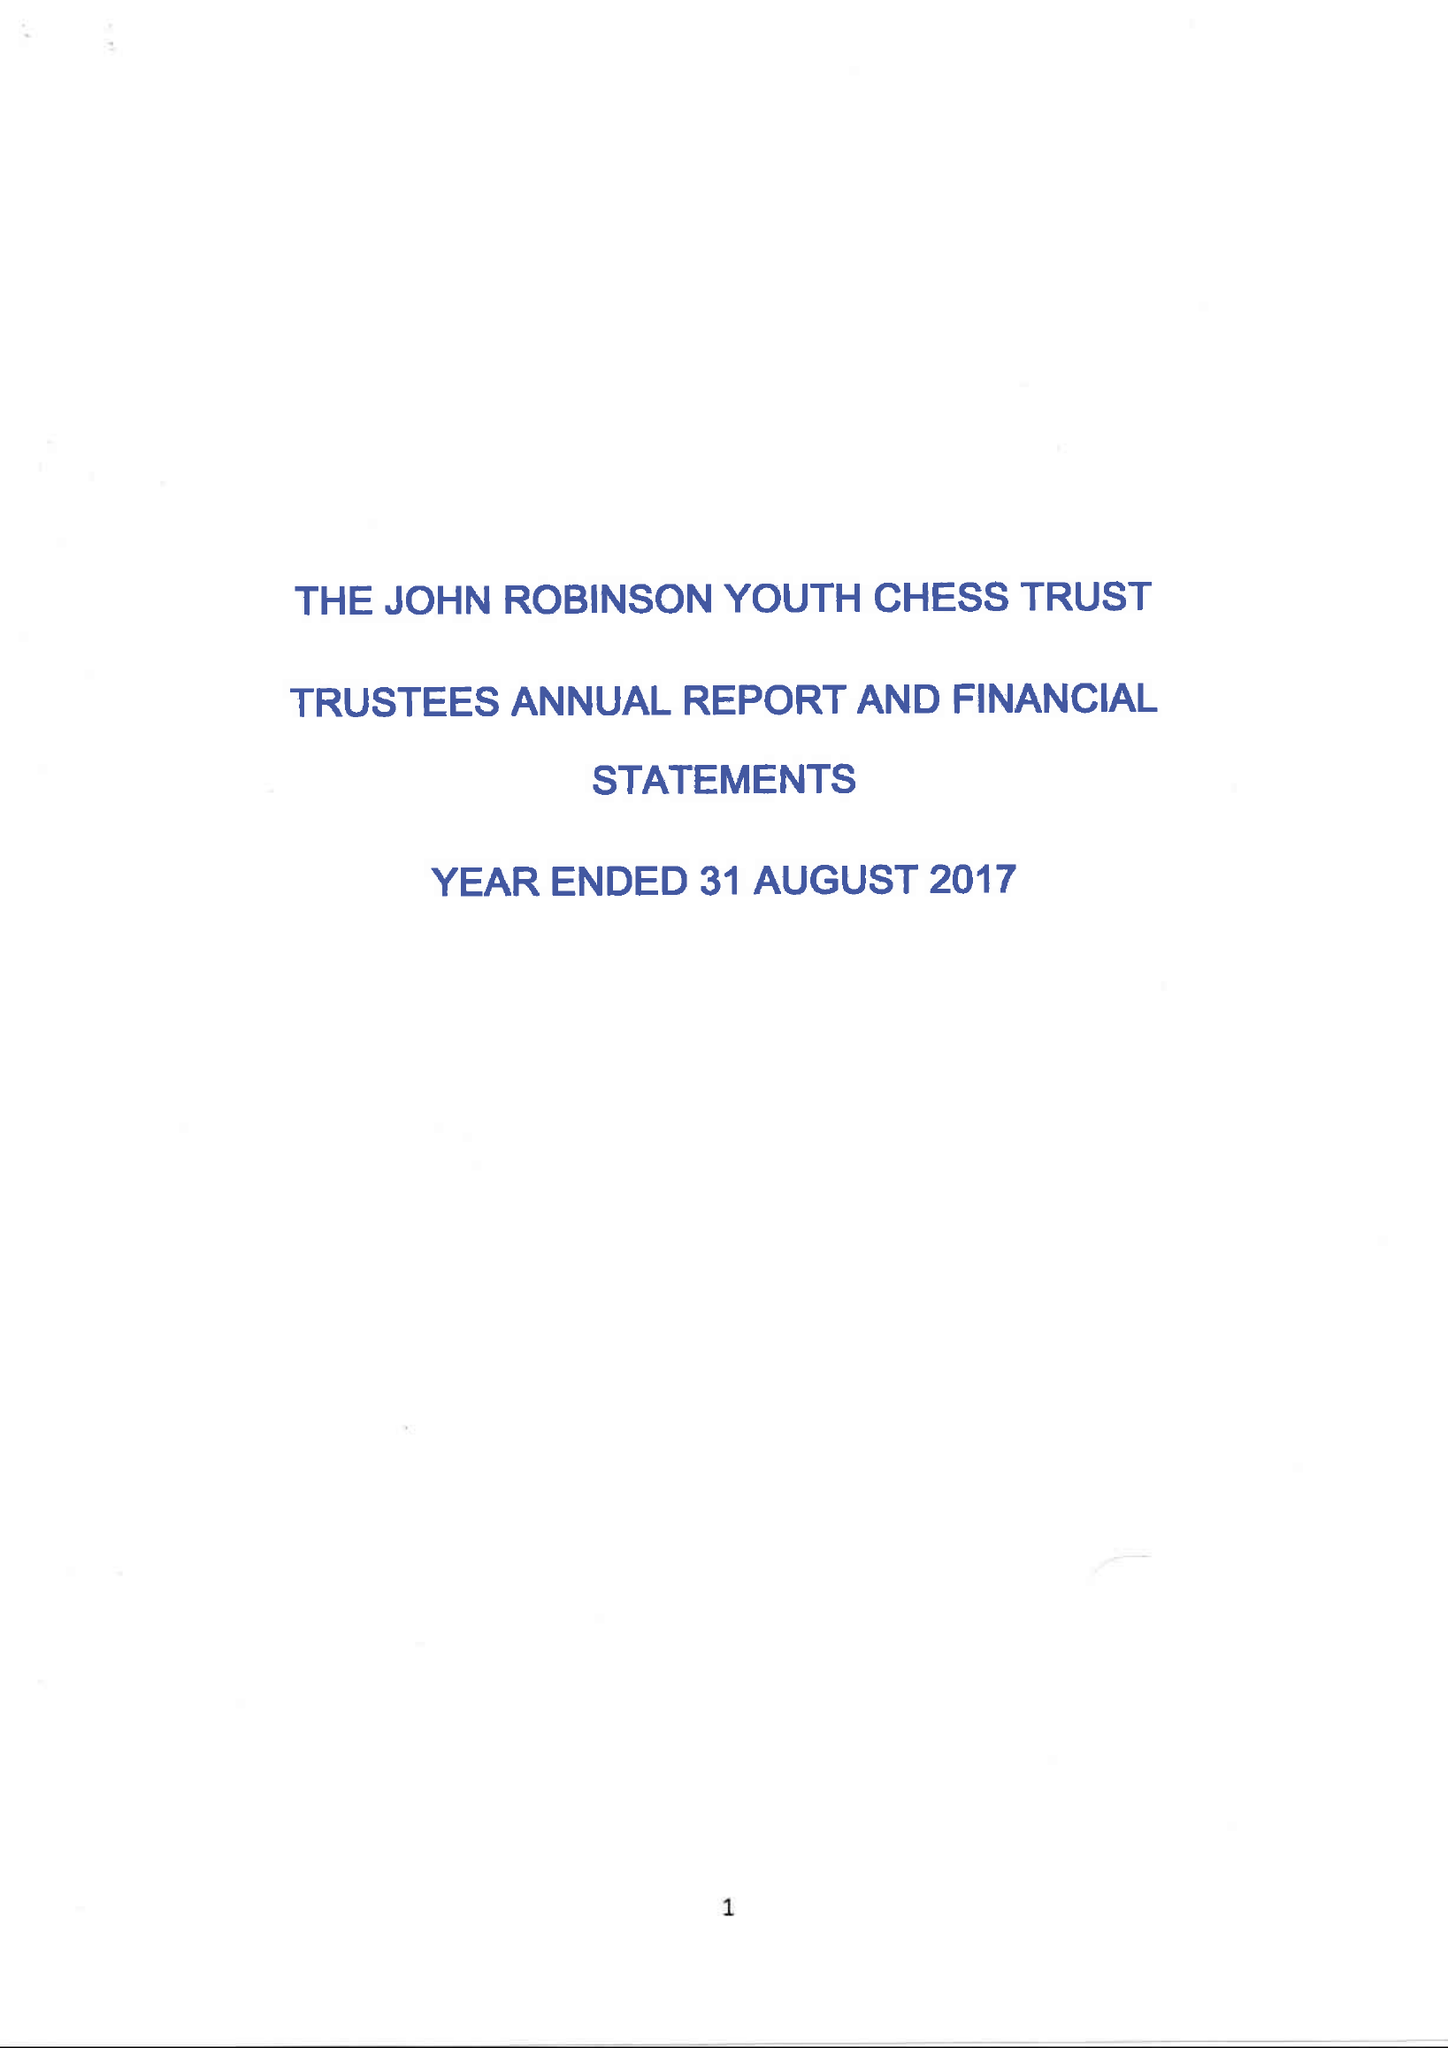What is the value for the address__postcode?
Answer the question using a single word or phrase. RH10 7FT 